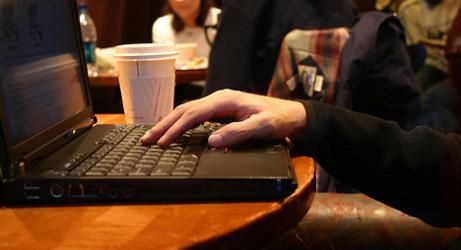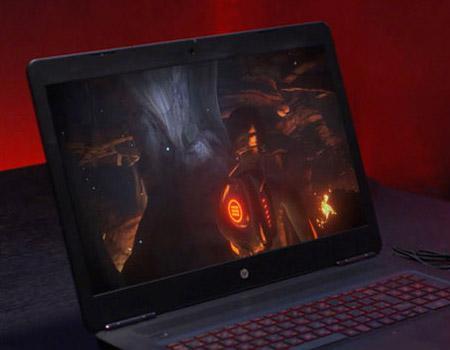The first image is the image on the left, the second image is the image on the right. Evaluate the accuracy of this statement regarding the images: "An image shows one man looking at an open laptop witth his feet propped up.". Is it true? Answer yes or no. No. The first image is the image on the left, the second image is the image on the right. Examine the images to the left and right. Is the description "In the image to the left, we can see exactly one guy; his upper body and face are quite visible and are obvious targets of the image." accurate? Answer yes or no. No. 